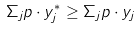<formula> <loc_0><loc_0><loc_500><loc_500>\Sigma _ { j } p \cdot y _ { j } ^ { * } \geq \Sigma _ { j } p \cdot y _ { j }</formula> 